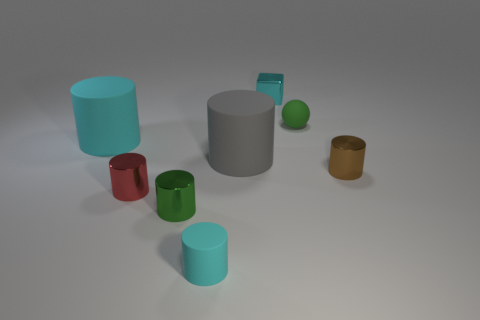Is the size of the gray object the same as the brown object?
Make the answer very short. No. There is a gray thing that is the same shape as the tiny red shiny object; what is it made of?
Provide a succinct answer. Rubber. Is there anything else that is made of the same material as the green ball?
Your answer should be compact. Yes. How many red things are either tiny shiny things or small matte things?
Make the answer very short. 1. There is a cyan thing that is in front of the tiny red thing; what material is it?
Your answer should be compact. Rubber. Are there more tiny blocks than tiny gray shiny balls?
Your answer should be very brief. Yes. Do the green thing that is in front of the brown metal thing and the gray object have the same shape?
Provide a succinct answer. Yes. What number of cyan objects are both in front of the tiny green matte thing and behind the gray rubber thing?
Your answer should be very brief. 1. What number of other tiny objects have the same shape as the brown object?
Offer a very short reply. 3. There is a large object to the left of the tiny green thing on the left side of the block; what is its color?
Ensure brevity in your answer.  Cyan. 